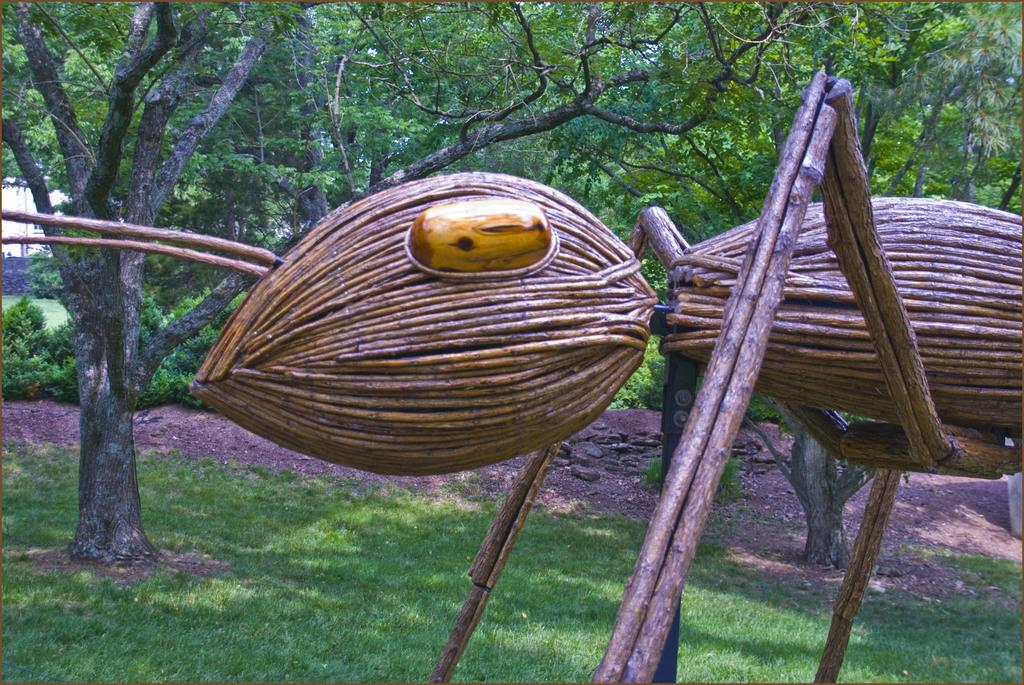What is the main subject of the image? The main subject of the image is an ant made up of wood. What can be seen in the background of the image? There are trees in the background of the image. How many cows are present in the image? There are no cows present in the image. What type of rabbit can be seen teaching a class in the image? There is no rabbit or teaching activity depicted in the image. 